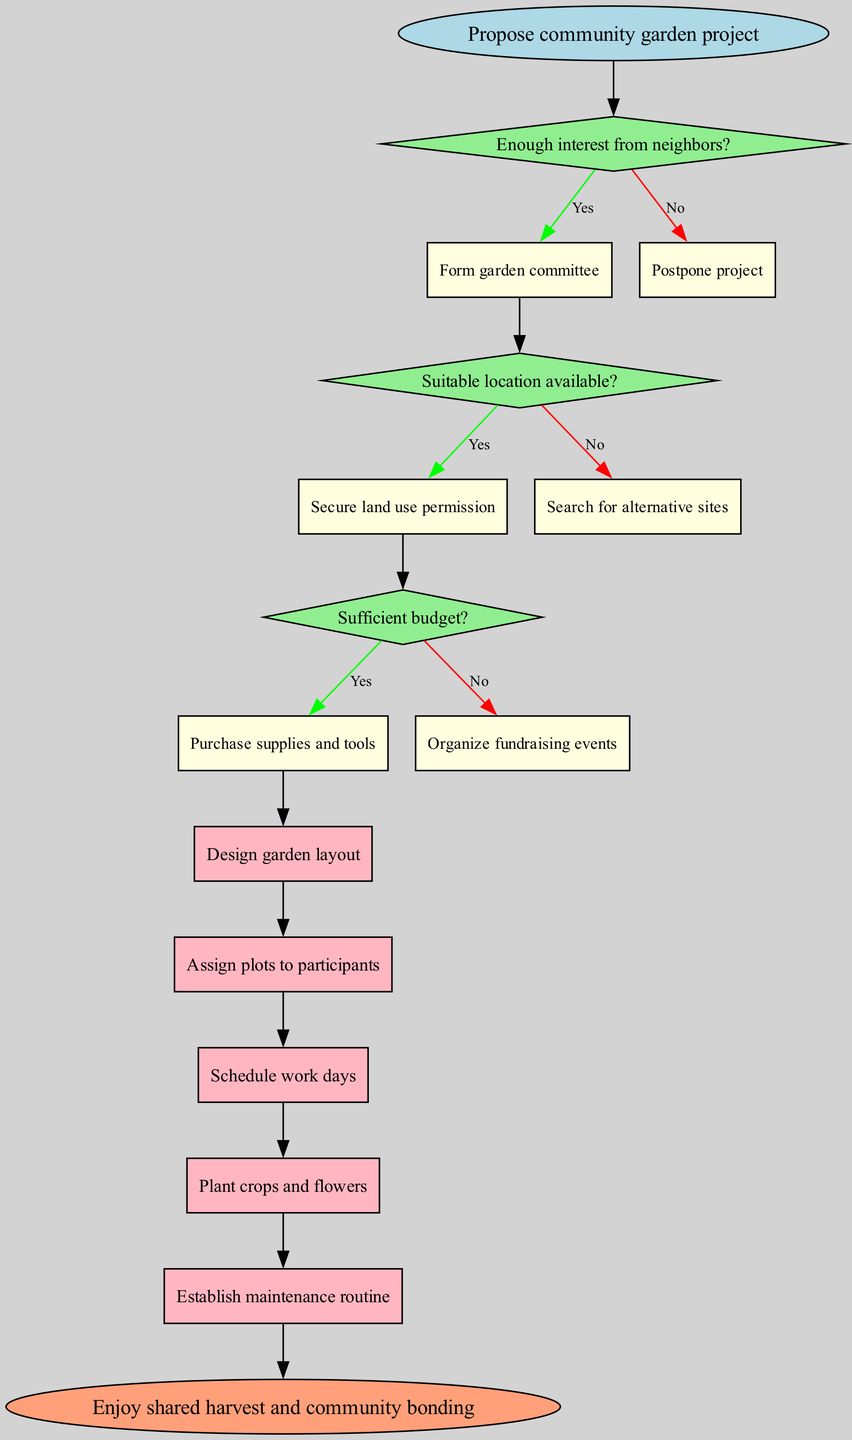What is the first step in the flowchart? The flowchart begins with the start node that states "Propose community garden project". This directly indicates that it is the initial action to take in managing the garden project.
Answer: Propose community garden project How many decision nodes are present in the diagram? There are three decision nodes represented by questions about neighbors' interest, suitable location, and budget. Counting these gives a total of three decision nodes.
Answer: 3 What happens if there is enough interest from neighbors? If the answer to the "Enough interest from neighbors?" decision is "Yes", the process proceeds to "Form garden committee" as the next step. This indicates that forming a committee is the action taken if interest exists.
Answer: Form garden committee Which process comes after securing land use permission? After the "Secure land use permission" decision, the flowchart directs to the process "Design garden layout". This shows that designing follows securing permission for the garden's location.
Answer: Design garden layout What is the last process before the end of the flowchart? The last process listed before reaching the end node is "Establish maintenance routine". This implies that before the project concludes with community bonding, routine maintenance is a critical step.
Answer: Establish maintenance routine What does the diagram indicate if there is insufficient budget? When the decision regarding the "Sufficient budget?" is answered with "No", the flowchart suggests organizing fundraising events as the necessary action to address the budget issue.
Answer: Organize fundraising events How are the processes connected to one another in the flowchart? The processes are connected sequentially, meaning each process leads to the next one in a linear order. This connection is demonstrated with arrows that indicate the flow from one step to another.
Answer: Sequentially What is the final outcome of the flowchart? The end node states "Enjoy shared harvest and community bonding". This indicates that the ultimate goal of managing the garden project is to foster community spirit and enjoy the fruits of their labor.
Answer: Enjoy shared harvest and community bonding 